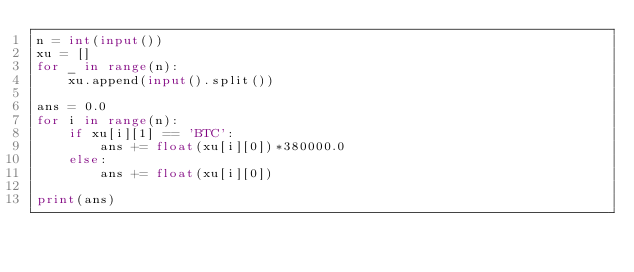<code> <loc_0><loc_0><loc_500><loc_500><_Python_>n = int(input())
xu = []
for _ in range(n):
    xu.append(input().split()) 

ans = 0.0
for i in range(n):
    if xu[i][1] == 'BTC':
        ans += float(xu[i][0])*380000.0
    else:
        ans += float(xu[i][0])

print(ans)</code> 